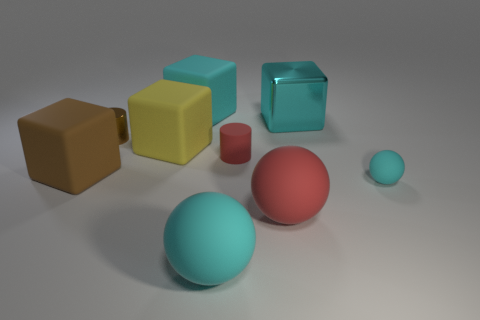The cylinder that is to the left of the large cyan matte thing to the left of the large cyan sphere is what color?
Keep it short and to the point. Brown. Are any large purple things visible?
Your answer should be very brief. No. What is the color of the small object that is on the right side of the large cyan matte block and to the left of the big cyan shiny object?
Your answer should be compact. Red. Does the red rubber thing in front of the big brown block have the same size as the red thing that is behind the large brown matte block?
Offer a terse response. No. What number of other objects are there of the same size as the red matte sphere?
Provide a succinct answer. 5. What number of tiny objects are on the left side of the large cyan rubber object that is behind the big brown rubber cube?
Your answer should be compact. 1. Are there fewer matte balls left of the tiny cyan sphere than cyan things?
Give a very brief answer. Yes. There is a metallic object behind the cylinder that is to the left of the big object in front of the big red rubber ball; what is its shape?
Offer a very short reply. Cube. Is the large brown object the same shape as the small cyan rubber thing?
Provide a short and direct response. No. What number of other things are there of the same shape as the big yellow rubber object?
Make the answer very short. 3. 